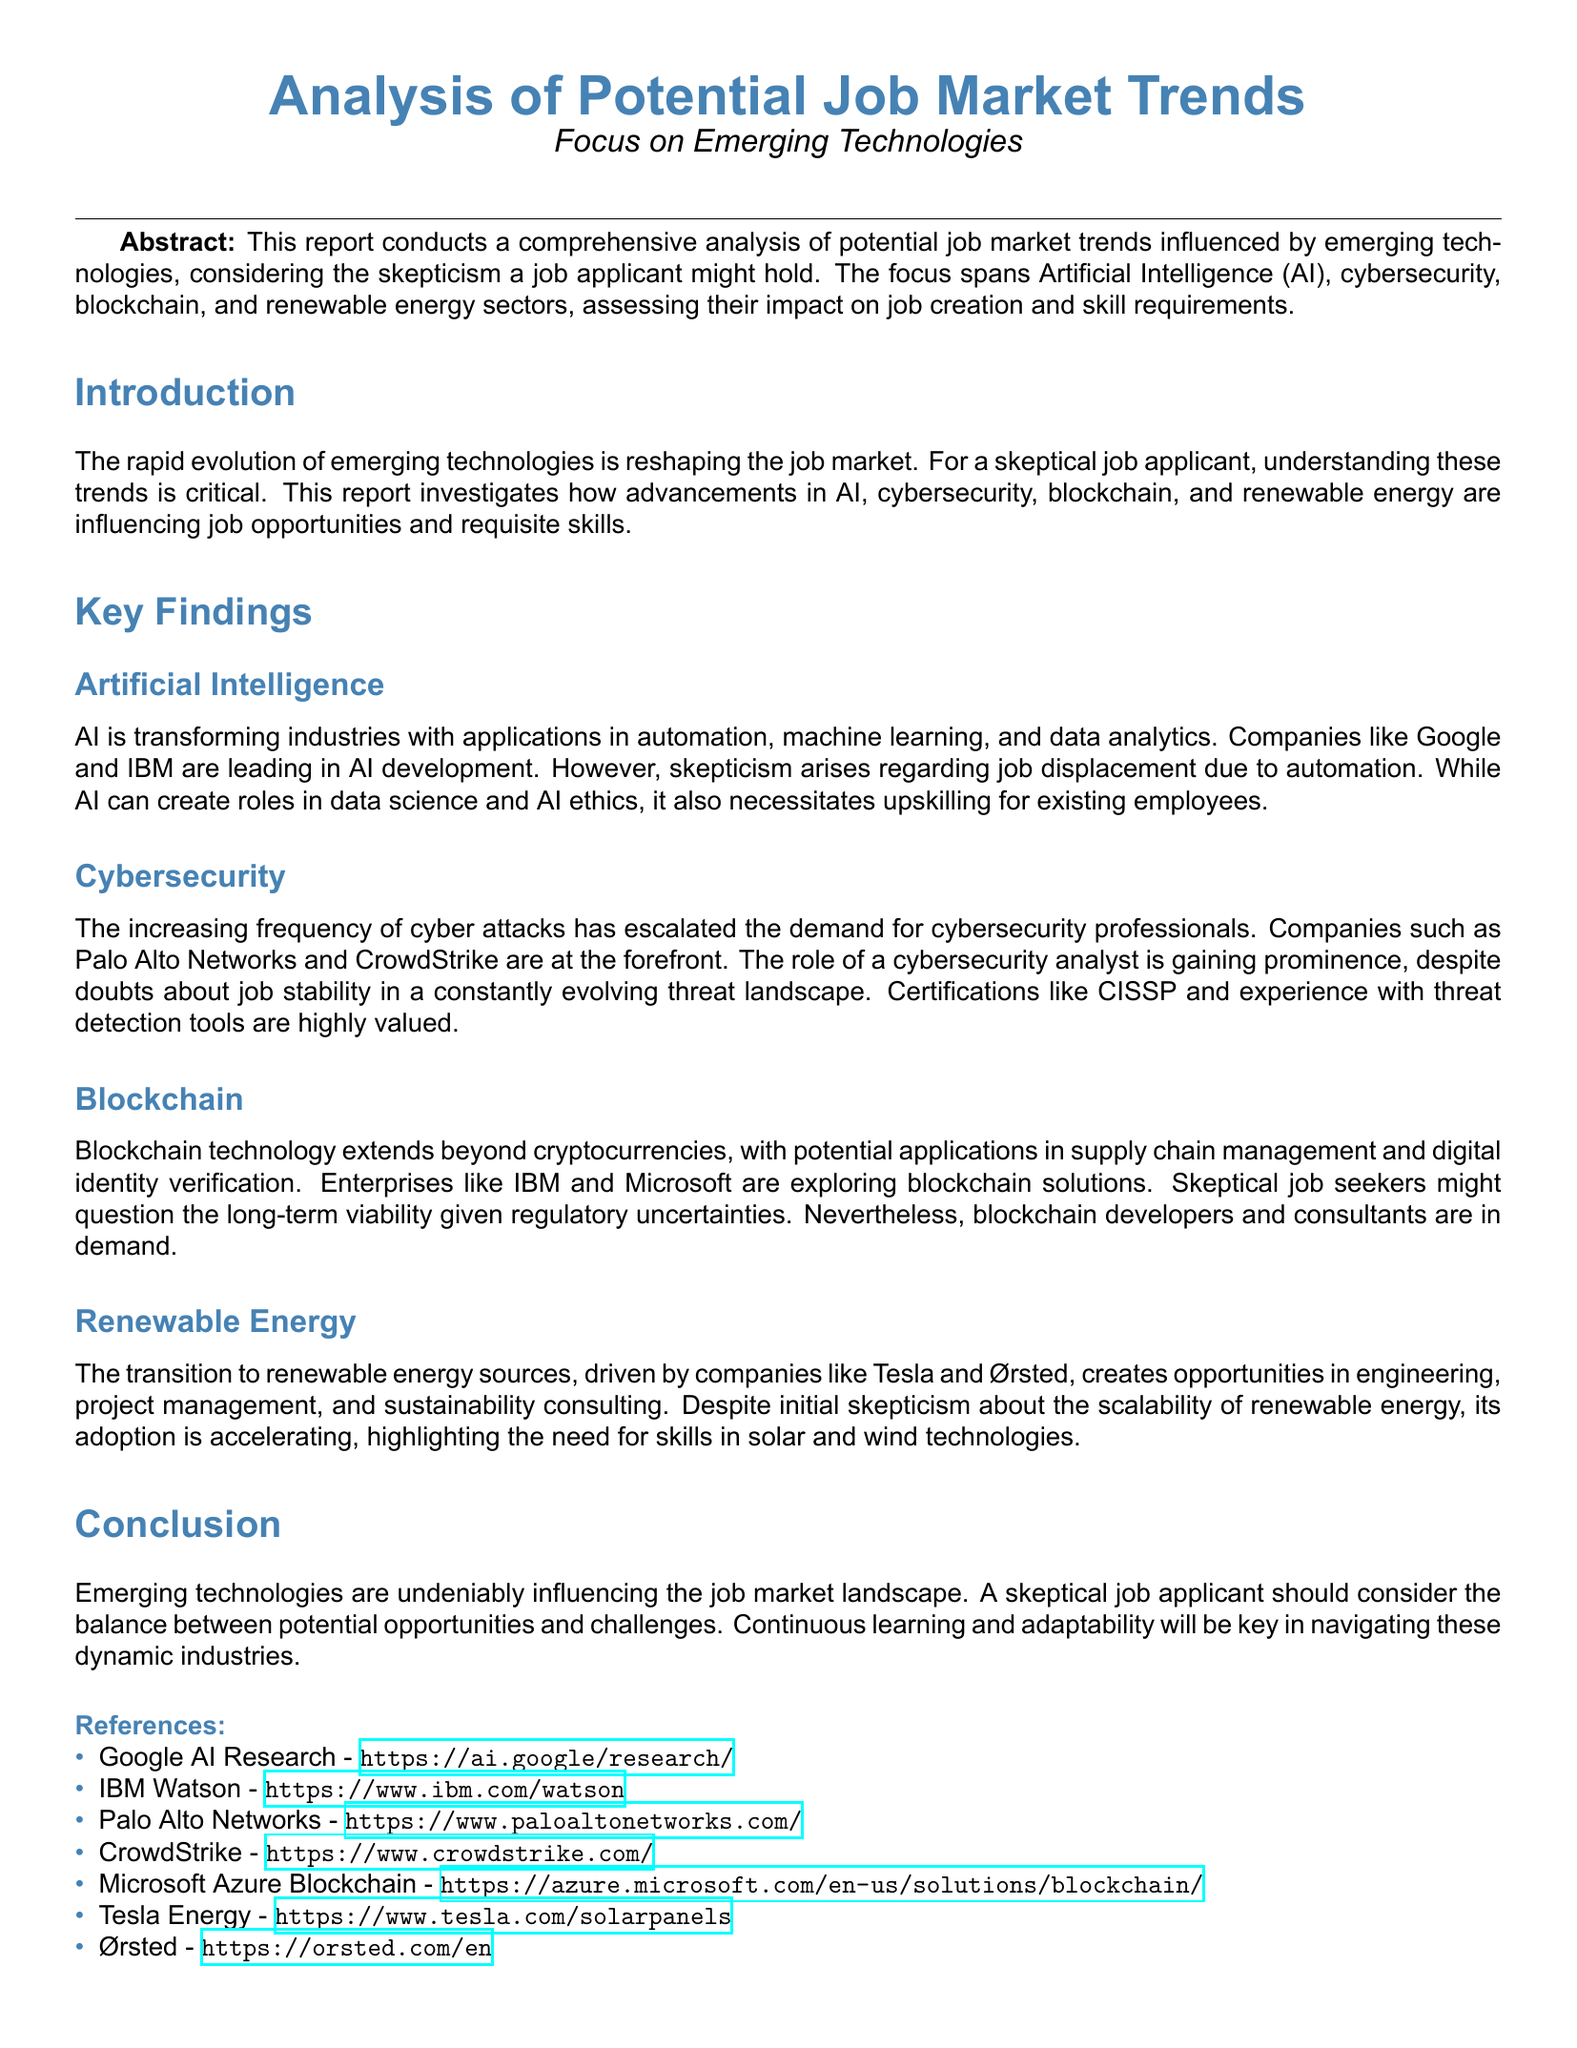What industries are being transformed by AI? The document states that AI is transforming industries including automation, machine learning, and data analytics.
Answer: automation, machine learning, data analytics Which companies are mentioned as leaders in AI development? Companies like Google and IBM are mentioned as leading in AI development.
Answer: Google, IBM What role is gaining prominence in cybersecurity? The document notes that the role of a cybersecurity analyst is gaining prominence.
Answer: cybersecurity analyst Name a certification that is highly valued in cybersecurity. The report mentions that certifications like CISSP are highly valued.
Answer: CISSP What applications does blockchain technology extend beyond? Blockchain technology extends beyond cryptocurrencies to applications like supply chain management and digital identity verification.
Answer: supply chain management, digital identity verification Which two companies are associated with renewable energy? Companies mentioned in renewable energy are Tesla and Ørsted.
Answer: Tesla, Ørsted What is a significant challenge in emerging technologies according to the conclusion? The conclusion highlights the balance between potential opportunities and challenges as a significant challenge.
Answer: challenges What type of skills does renewable energy adoption highlight? The document emphasizes the need for skills in solar and wind technologies.
Answer: solar and wind technologies Which section assesses the impact on job creation? The Key Findings section assesses the impact on job creation.
Answer: Key Findings 